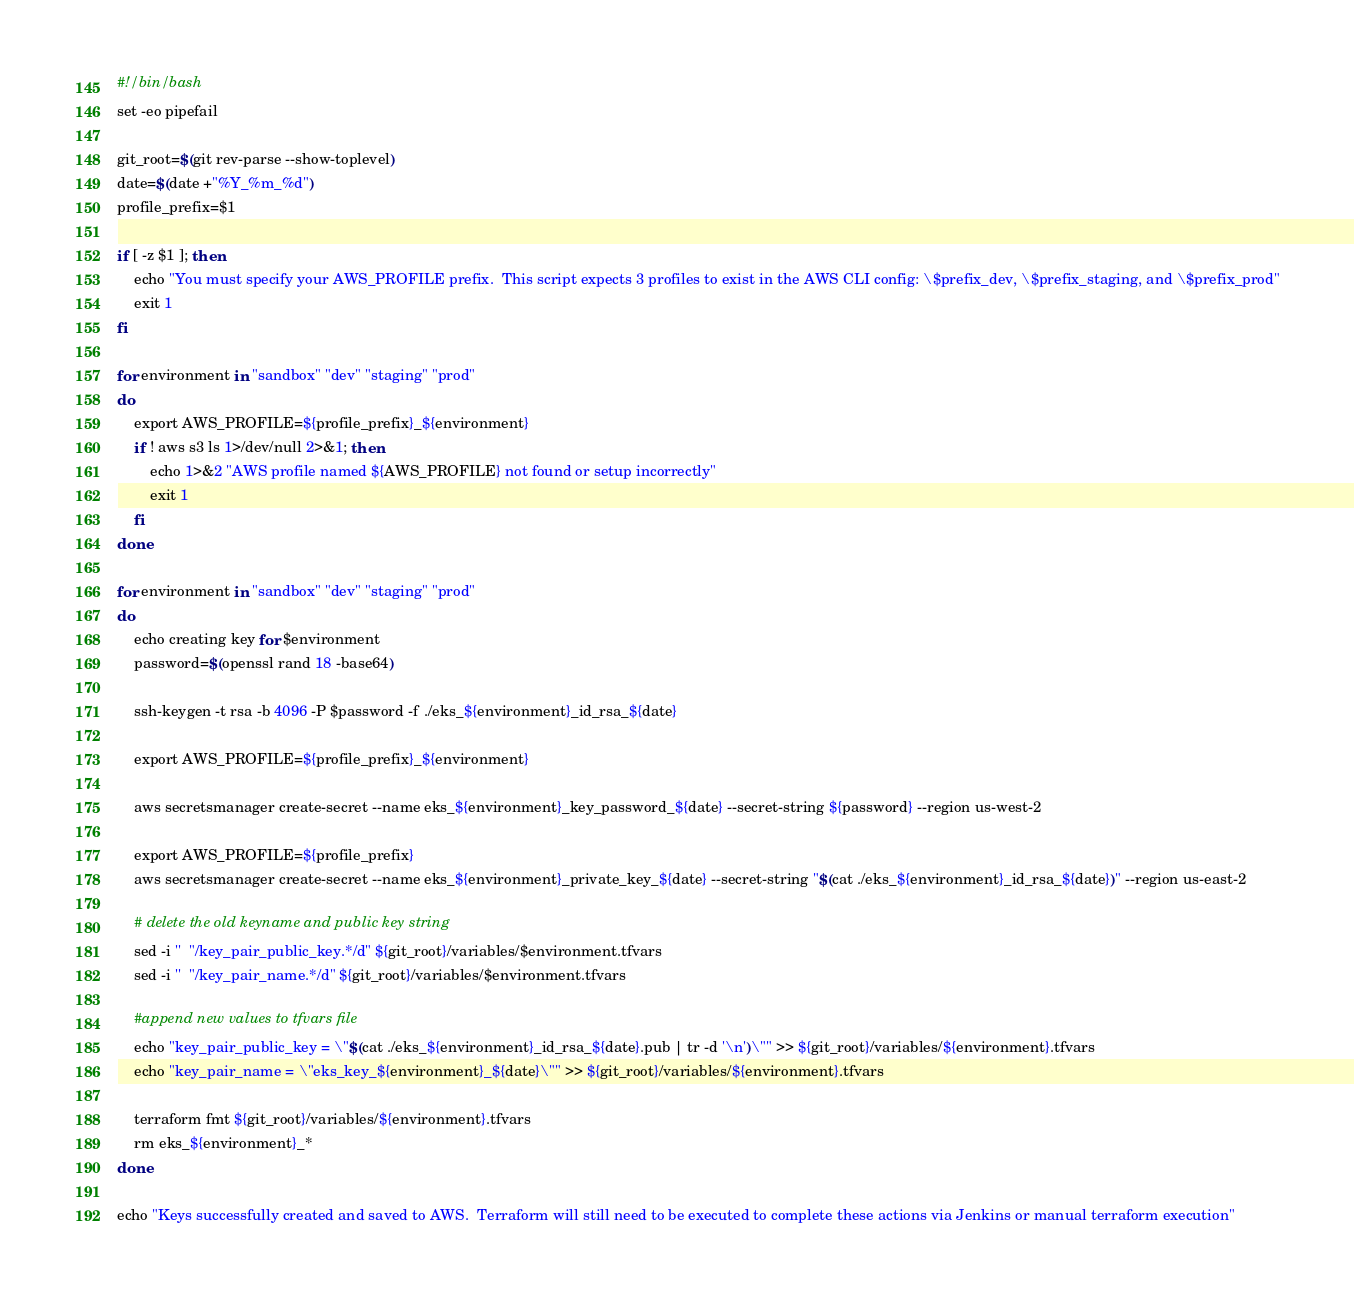<code> <loc_0><loc_0><loc_500><loc_500><_Bash_>#!/bin/bash
set -eo pipefail

git_root=$(git rev-parse --show-toplevel)
date=$(date +"%Y_%m_%d")
profile_prefix=$1

if [ -z $1 ]; then
    echo "You must specify your AWS_PROFILE prefix.  This script expects 3 profiles to exist in the AWS CLI config: \$prefix_dev, \$prefix_staging, and \$prefix_prod"
    exit 1
fi

for environment in "sandbox" "dev" "staging" "prod"
do
    export AWS_PROFILE=${profile_prefix}_${environment}
    if ! aws s3 ls 1>/dev/null 2>&1; then
        echo 1>&2 "AWS profile named ${AWS_PROFILE} not found or setup incorrectly"
        exit 1
    fi
done

for environment in "sandbox" "dev" "staging" "prod"
do
    echo creating key for $environment
    password=$(openssl rand 18 -base64)

    ssh-keygen -t rsa -b 4096 -P $password -f ./eks_${environment}_id_rsa_${date}

    export AWS_PROFILE=${profile_prefix}_${environment}

    aws secretsmanager create-secret --name eks_${environment}_key_password_${date} --secret-string ${password} --region us-west-2

    export AWS_PROFILE=${profile_prefix}
    aws secretsmanager create-secret --name eks_${environment}_private_key_${date} --secret-string "$(cat ./eks_${environment}_id_rsa_${date})" --region us-east-2

    # delete the old keyname and public key string 
    sed -i ''  "/key_pair_public_key.*/d" ${git_root}/variables/$environment.tfvars
    sed -i ''  "/key_pair_name.*/d" ${git_root}/variables/$environment.tfvars

    #append new values to tfvars file
    echo "key_pair_public_key = \"$(cat ./eks_${environment}_id_rsa_${date}.pub | tr -d '\n')\"" >> ${git_root}/variables/${environment}.tfvars        
    echo "key_pair_name = \"eks_key_${environment}_${date}\"" >> ${git_root}/variables/${environment}.tfvars
    
    terraform fmt ${git_root}/variables/${environment}.tfvars
    rm eks_${environment}_*
done

echo "Keys successfully created and saved to AWS.  Terraform will still need to be executed to complete these actions via Jenkins or manual terraform execution"
</code> 